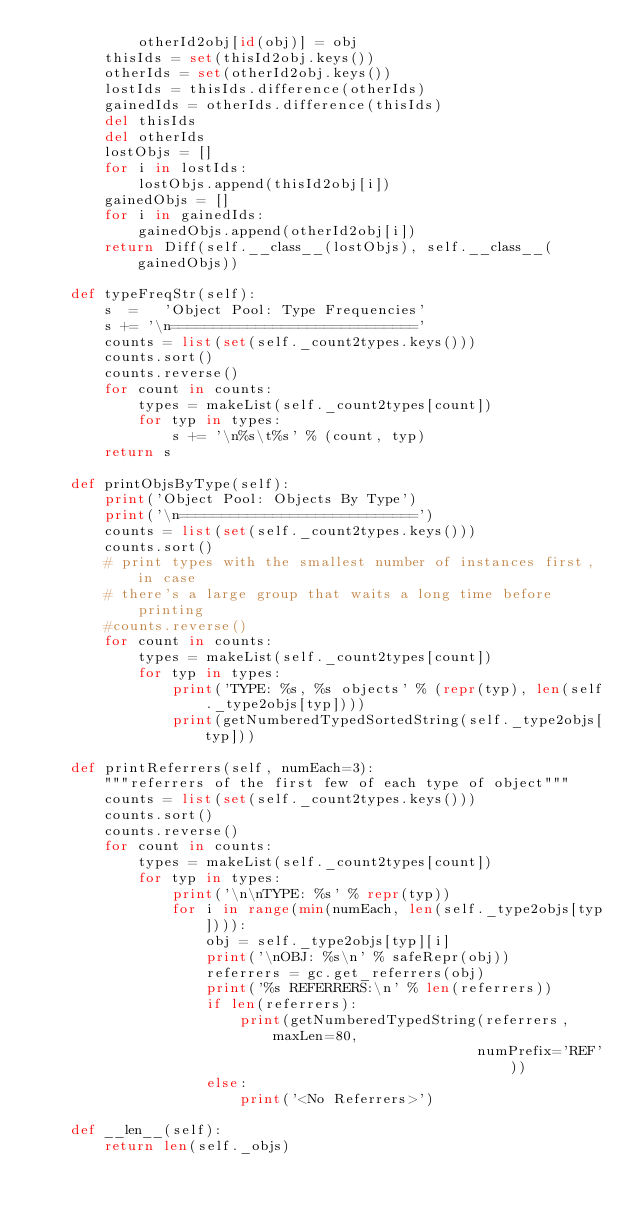<code> <loc_0><loc_0><loc_500><loc_500><_Python_>            otherId2obj[id(obj)] = obj
        thisIds = set(thisId2obj.keys())
        otherIds = set(otherId2obj.keys())
        lostIds = thisIds.difference(otherIds)
        gainedIds = otherIds.difference(thisIds)
        del thisIds
        del otherIds
        lostObjs = []
        for i in lostIds:
            lostObjs.append(thisId2obj[i])
        gainedObjs = []
        for i in gainedIds:
            gainedObjs.append(otherId2obj[i])
        return Diff(self.__class__(lostObjs), self.__class__(gainedObjs))

    def typeFreqStr(self):
        s  =   'Object Pool: Type Frequencies'
        s += '\n============================='
        counts = list(set(self._count2types.keys()))
        counts.sort()
        counts.reverse()
        for count in counts:
            types = makeList(self._count2types[count])
            for typ in types:
                s += '\n%s\t%s' % (count, typ)
        return s

    def printObjsByType(self):
        print('Object Pool: Objects By Type')
        print('\n============================')
        counts = list(set(self._count2types.keys()))
        counts.sort()
        # print types with the smallest number of instances first, in case
        # there's a large group that waits a long time before printing
        #counts.reverse()
        for count in counts:
            types = makeList(self._count2types[count])
            for typ in types:
                print('TYPE: %s, %s objects' % (repr(typ), len(self._type2objs[typ])))
                print(getNumberedTypedSortedString(self._type2objs[typ]))

    def printReferrers(self, numEach=3):
        """referrers of the first few of each type of object"""
        counts = list(set(self._count2types.keys()))
        counts.sort()
        counts.reverse()
        for count in counts:
            types = makeList(self._count2types[count])
            for typ in types:
                print('\n\nTYPE: %s' % repr(typ))
                for i in range(min(numEach, len(self._type2objs[typ]))):
                    obj = self._type2objs[typ][i]
                    print('\nOBJ: %s\n' % safeRepr(obj))
                    referrers = gc.get_referrers(obj)
                    print('%s REFERRERS:\n' % len(referrers))
                    if len(referrers):
                        print(getNumberedTypedString(referrers, maxLen=80,
                                                    numPrefix='REF'))
                    else:
                        print('<No Referrers>')

    def __len__(self):
        return len(self._objs)
</code> 